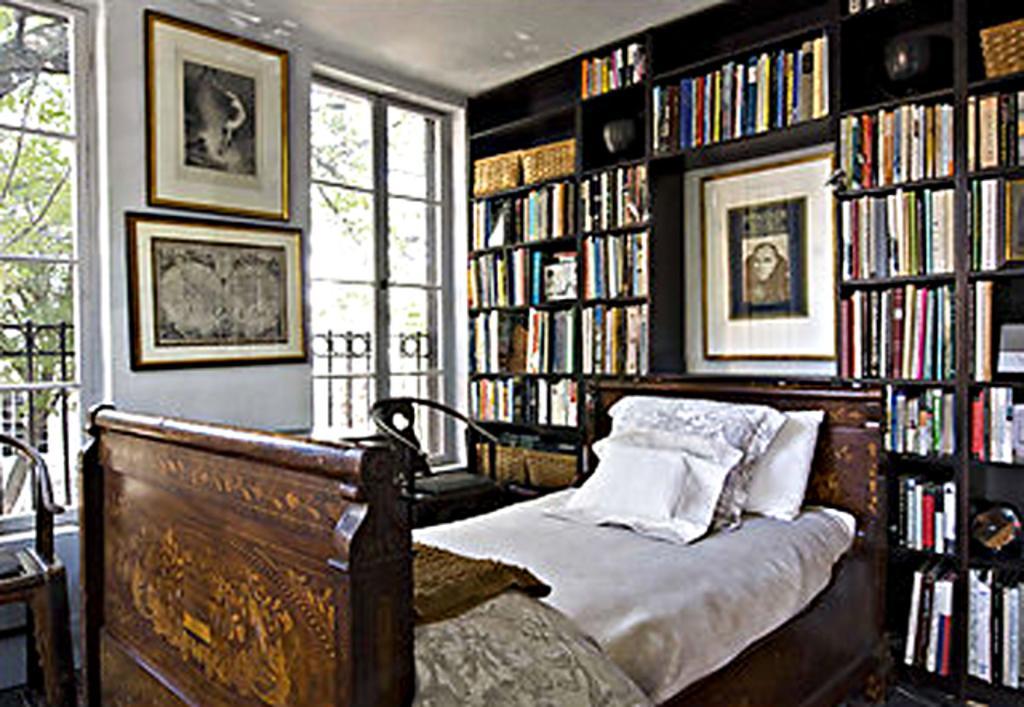Please provide a concise description of this image. Here in this picture there is cot, on the cot there is white color bed and we can also see three pillows on the bed. Behind that bed there is a bookshelf. And in the middle of the bookshelf there is a photo frame. To the left side there are two windows. In the middle of the windows there is a wall with two photo frames. In front of the right side window there is a chair. And in front of the left side window there is also a chair. 